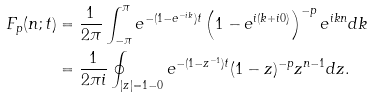Convert formula to latex. <formula><loc_0><loc_0><loc_500><loc_500>F _ { p } ( n ; t ) & = \frac { 1 } { 2 \pi } \int _ { - \pi } ^ { \pi } e ^ { - ( 1 - e ^ { - i k } ) t } \left ( 1 - e ^ { i ( k + i 0 ) } \right ) ^ { - p } e ^ { i k n } d k \\ & = \frac { 1 } { 2 \pi i } \oint _ { | z | = 1 - 0 } e ^ { - ( 1 - z ^ { - 1 } ) t } ( 1 - z ) ^ { - p } z ^ { n - 1 } d z .</formula> 